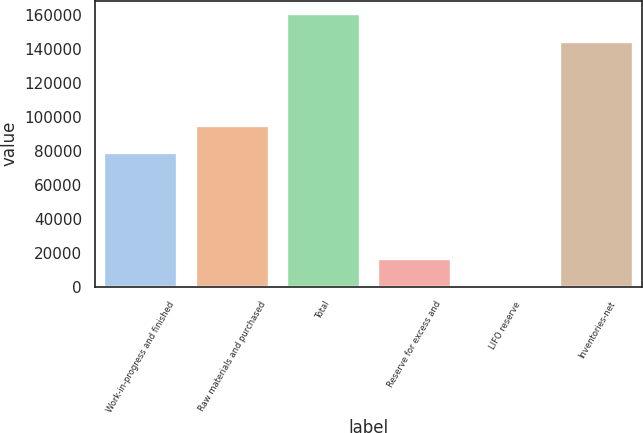<chart> <loc_0><loc_0><loc_500><loc_500><bar_chart><fcel>Work-in-progress and finished<fcel>Raw materials and purchased<fcel>Total<fcel>Reserve for excess and<fcel>LIFO reserve<fcel>Inventories-net<nl><fcel>78467<fcel>94464.6<fcel>160217<fcel>16238.6<fcel>241<fcel>144114<nl></chart> 